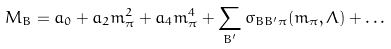Convert formula to latex. <formula><loc_0><loc_0><loc_500><loc_500>M _ { B } = a _ { 0 } + a _ { 2 } m _ { \pi } ^ { 2 } + a _ { 4 } m _ { \pi } ^ { 4 } + \sum _ { B ^ { \prime } } \sigma _ { B B ^ { \prime } \pi } ( m _ { \pi } , \Lambda ) + \dots</formula> 